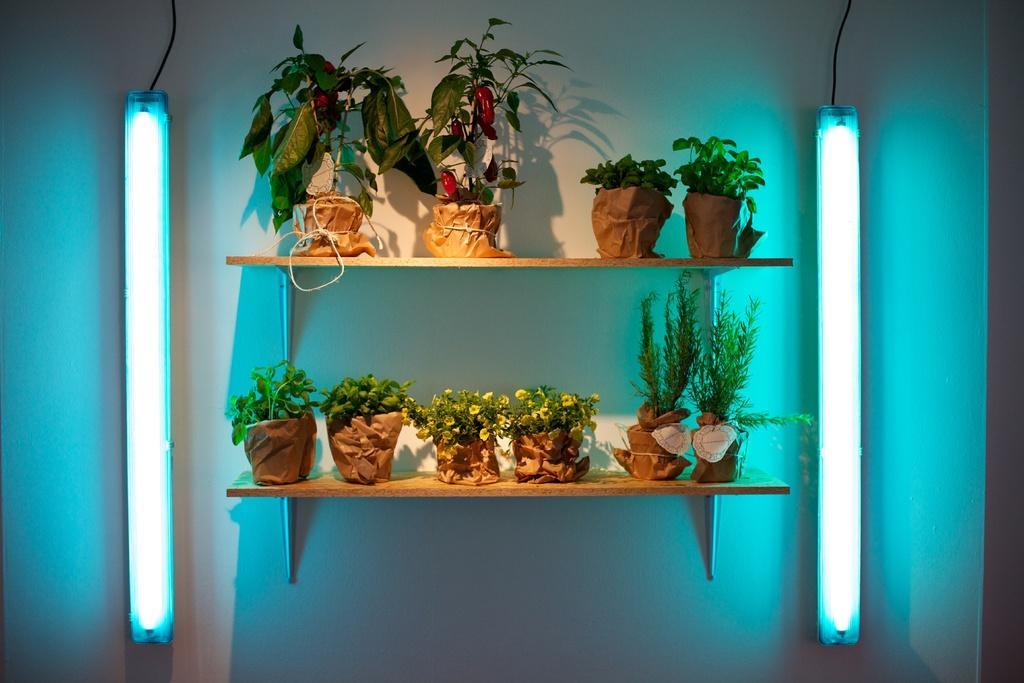Describe this image in one or two sentences. In this image we can see some flower pots which are arranged on the shelves and there are some lights at left and right side of the image which are attached to the wall. 